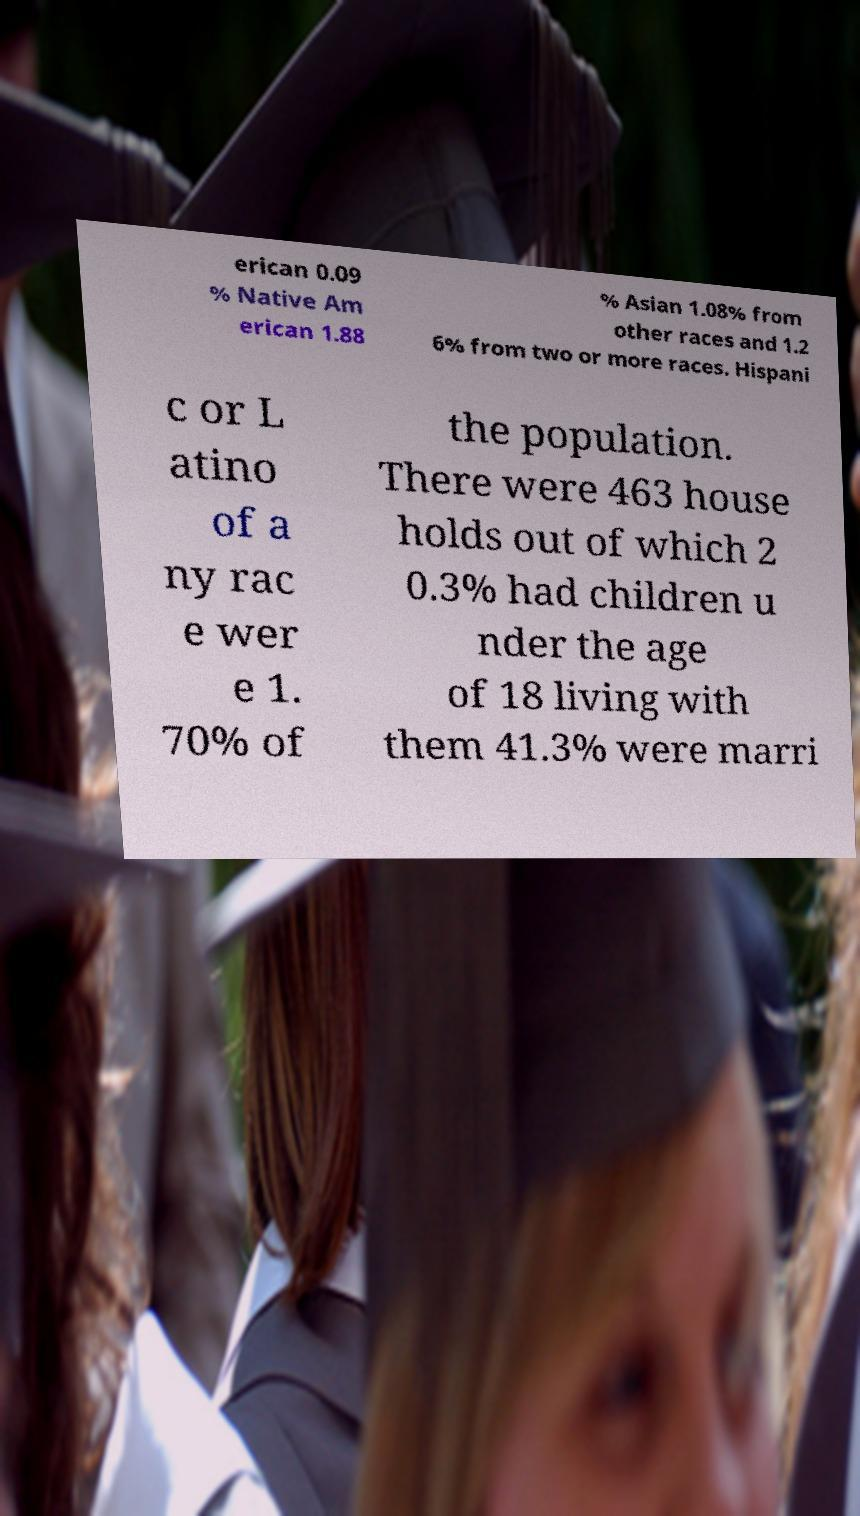Can you accurately transcribe the text from the provided image for me? erican 0.09 % Native Am erican 1.88 % Asian 1.08% from other races and 1.2 6% from two or more races. Hispani c or L atino of a ny rac e wer e 1. 70% of the population. There were 463 house holds out of which 2 0.3% had children u nder the age of 18 living with them 41.3% were marri 